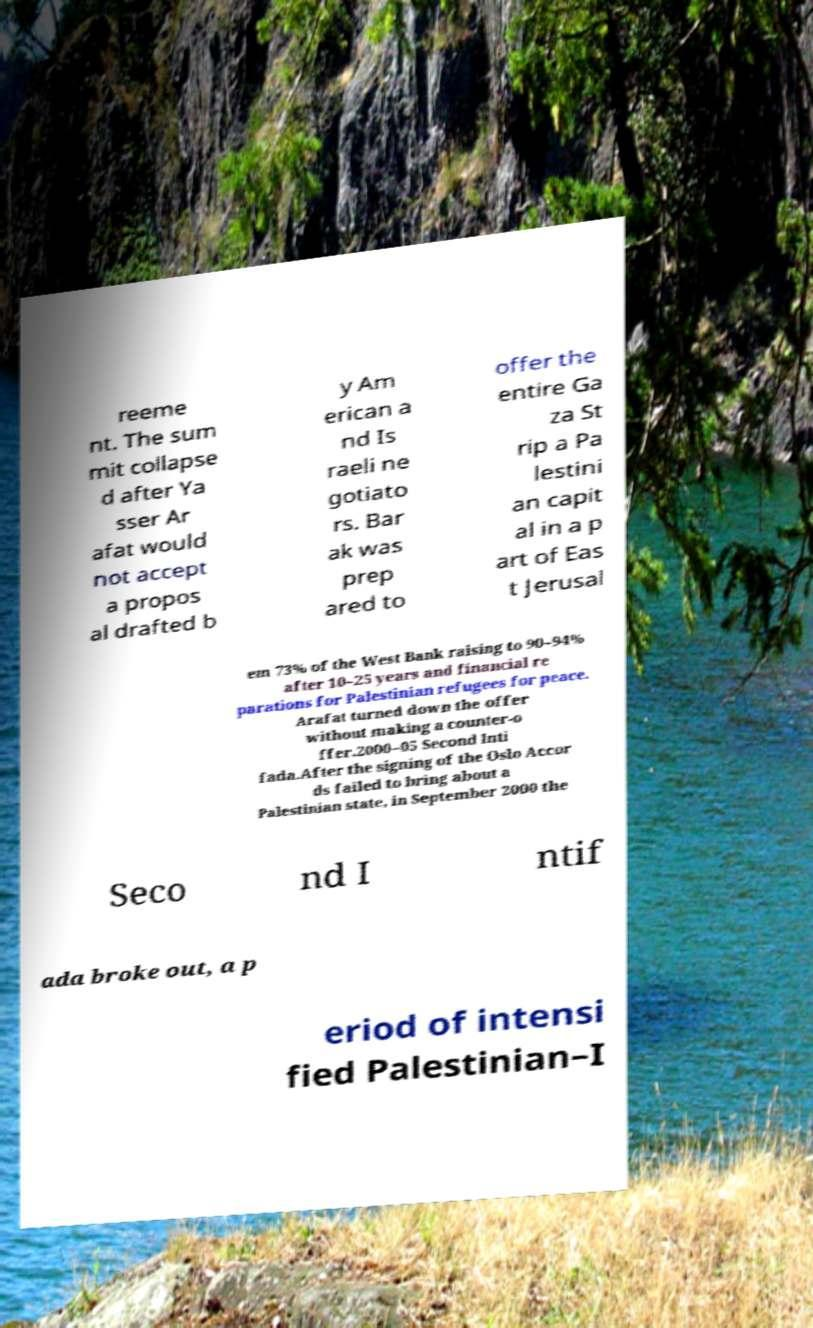Could you assist in decoding the text presented in this image and type it out clearly? reeme nt. The sum mit collapse d after Ya sser Ar afat would not accept a propos al drafted b y Am erican a nd Is raeli ne gotiato rs. Bar ak was prep ared to offer the entire Ga za St rip a Pa lestini an capit al in a p art of Eas t Jerusal em 73% of the West Bank raising to 90–94% after 10–25 years and financial re parations for Palestinian refugees for peace. Arafat turned down the offer without making a counter-o ffer.2000–05 Second Inti fada.After the signing of the Oslo Accor ds failed to bring about a Palestinian state, in September 2000 the Seco nd I ntif ada broke out, a p eriod of intensi fied Palestinian–I 